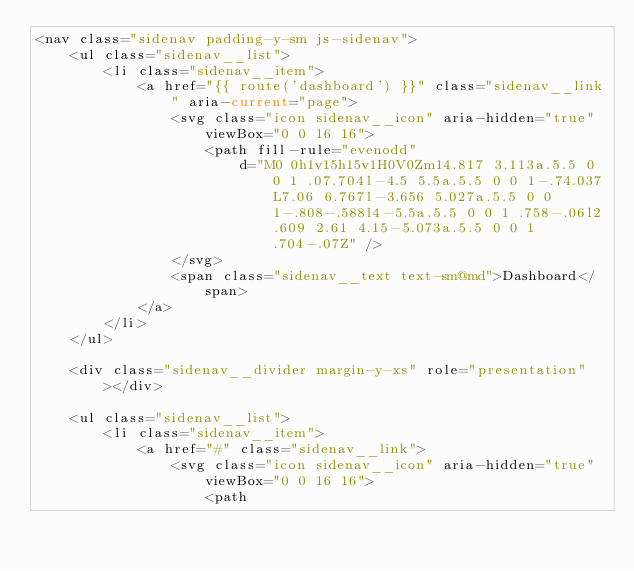<code> <loc_0><loc_0><loc_500><loc_500><_PHP_><nav class="sidenav padding-y-sm js-sidenav">
    <ul class="sidenav__list">
        <li class="sidenav__item">
            <a href="{{ route('dashboard') }}" class="sidenav__link" aria-current="page">
                <svg class="icon sidenav__icon" aria-hidden="true" viewBox="0 0 16 16">
                    <path fill-rule="evenodd"
                        d="M0 0h1v15h15v1H0V0Zm14.817 3.113a.5.5 0 0 1 .07.704l-4.5 5.5a.5.5 0 0 1-.74.037L7.06 6.767l-3.656 5.027a.5.5 0 0 1-.808-.588l4-5.5a.5.5 0 0 1 .758-.06l2.609 2.61 4.15-5.073a.5.5 0 0 1 .704-.07Z" />
                </svg>
                <span class="sidenav__text text-sm@md">Dashboard</span>
            </a>
        </li>
    </ul>

    <div class="sidenav__divider margin-y-xs" role="presentation"></div>

    <ul class="sidenav__list">
        <li class="sidenav__item">
            <a href="#" class="sidenav__link">
                <svg class="icon sidenav__icon" aria-hidden="true" viewBox="0 0 16 16">
                    <path</code> 